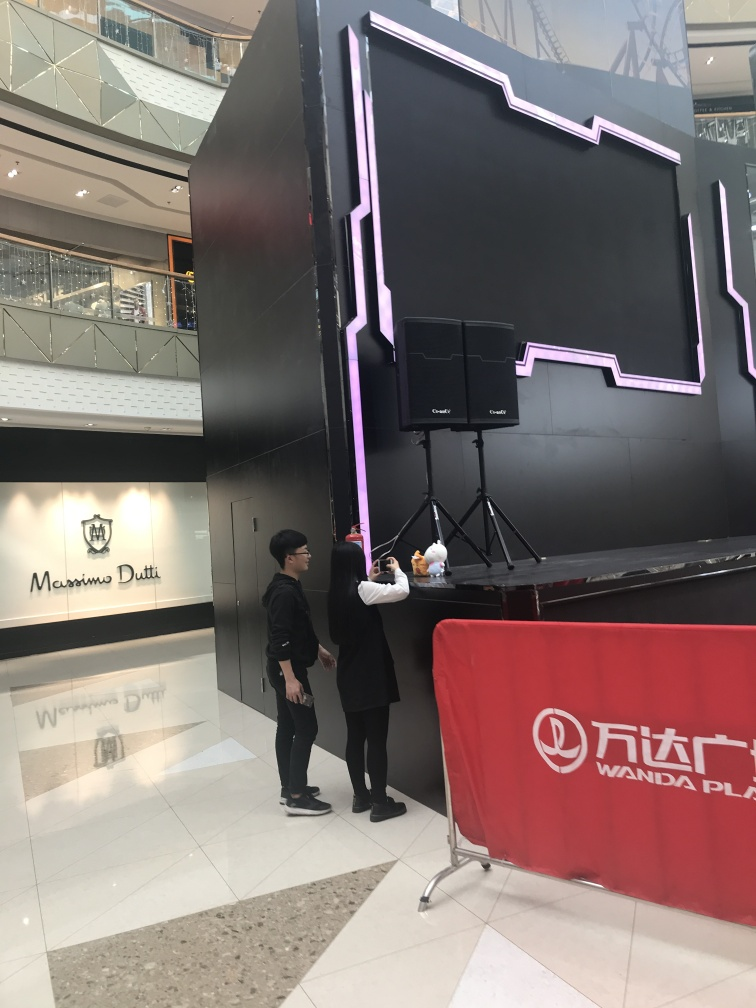Can you tell me more about the location depicted in the image? This image appears to be taken inside a modern shopping center. The presence of logo signage for 'Massimo Dutti,' a high-end clothing brand, suggests it might be a premium retail area. The 'Wanda Plaza' branding on the red barricade indicates the location may be part of Wanda Group's chain of malls, which are common in China. What does the structure with neon lights seem to be? It resembles a promotional installation or decorative feature often found in commercial spaces. The neon lights give it a striking appearance, potentially designed to attract attention or as part of a thematic display possibly associated with an event or product launch taking place within the mall. 